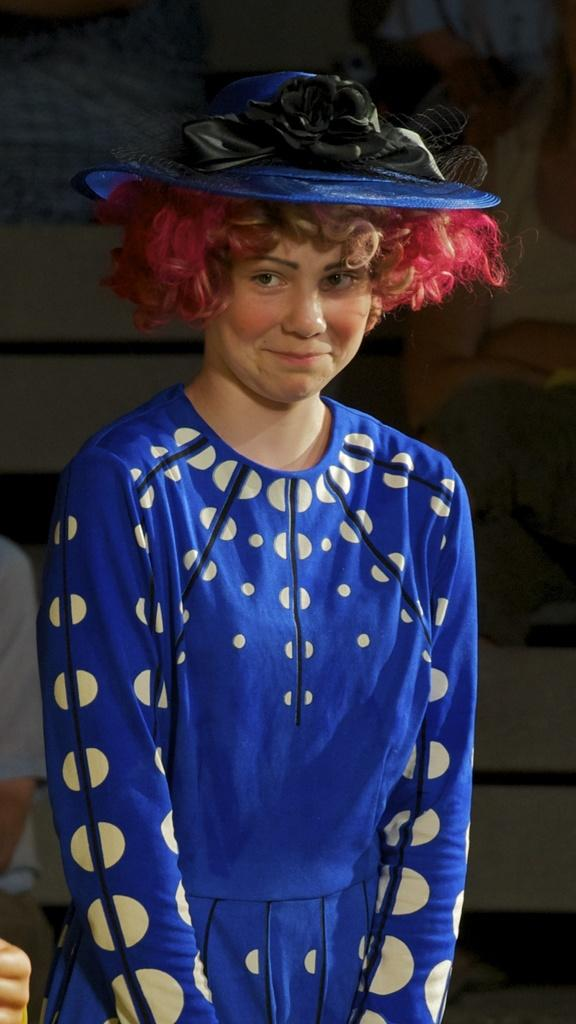Who is the main subject in the image? There is a girl in the image. What is the girl wearing? The girl is wearing a blue dress and a blue hat. How is the girl positioned in the image? The girl is standing with a smile on her face. What type of giants can be seen in the image? There are no giants present in the image; it features a girl wearing a blue dress and hat. How many rabbits are visible in the image? There are no rabbits present in the image. 